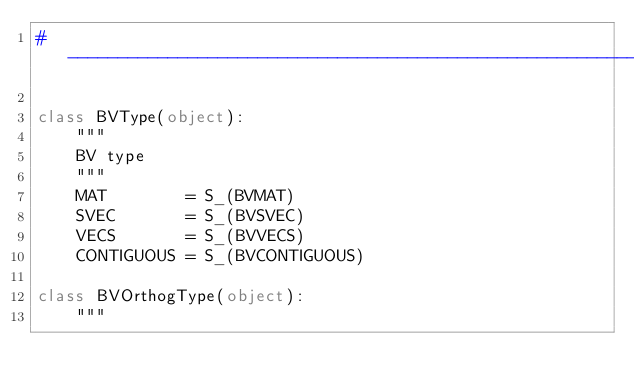Convert code to text. <code><loc_0><loc_0><loc_500><loc_500><_Cython_># -----------------------------------------------------------------------------

class BVType(object):
    """
    BV type
    """
    MAT        = S_(BVMAT)
    SVEC       = S_(BVSVEC)
    VECS       = S_(BVVECS)
    CONTIGUOUS = S_(BVCONTIGUOUS)

class BVOrthogType(object):
    """</code> 